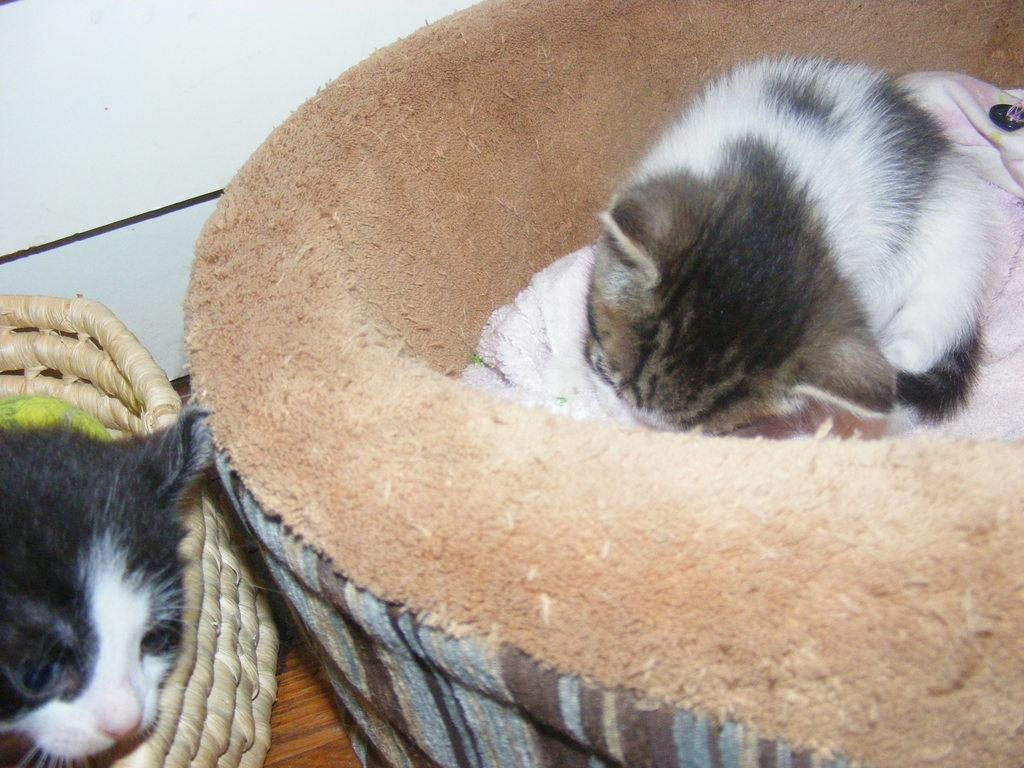How many cats are present in the image? There are two cats in the image. What are the cats doing in the image? The cats are in pet beds. What can be seen in the background of the image? There is a sky visible in the background of the image. What type of plantation can be seen in the image? There is no plantation present in the image; it features two cats in pet beds with a sky visible in the background. How many bears are visible in the image? There are no bears present in the image. 